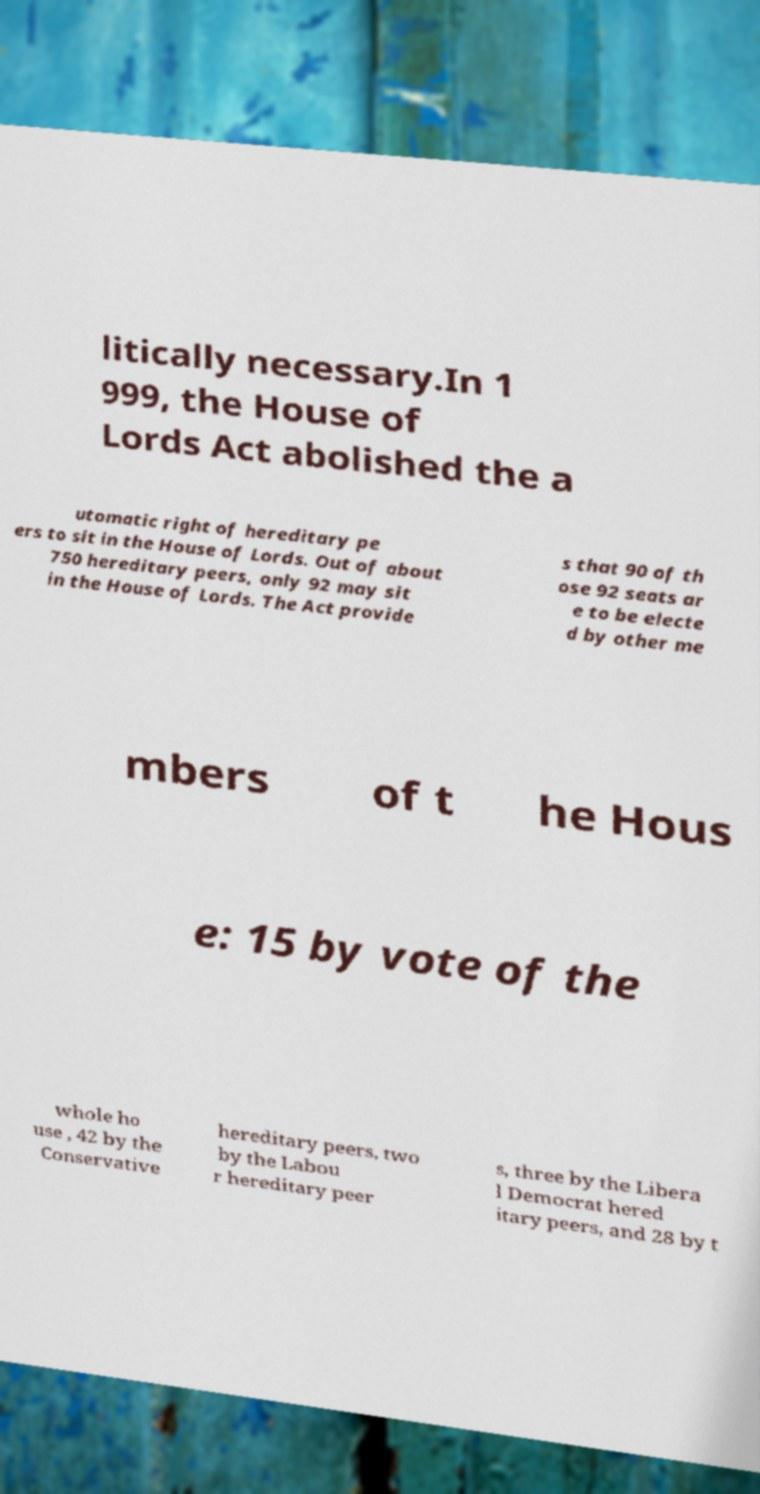Please identify and transcribe the text found in this image. litically necessary.In 1 999, the House of Lords Act abolished the a utomatic right of hereditary pe ers to sit in the House of Lords. Out of about 750 hereditary peers, only 92 may sit in the House of Lords. The Act provide s that 90 of th ose 92 seats ar e to be electe d by other me mbers of t he Hous e: 15 by vote of the whole ho use , 42 by the Conservative hereditary peers, two by the Labou r hereditary peer s, three by the Libera l Democrat hered itary peers, and 28 by t 